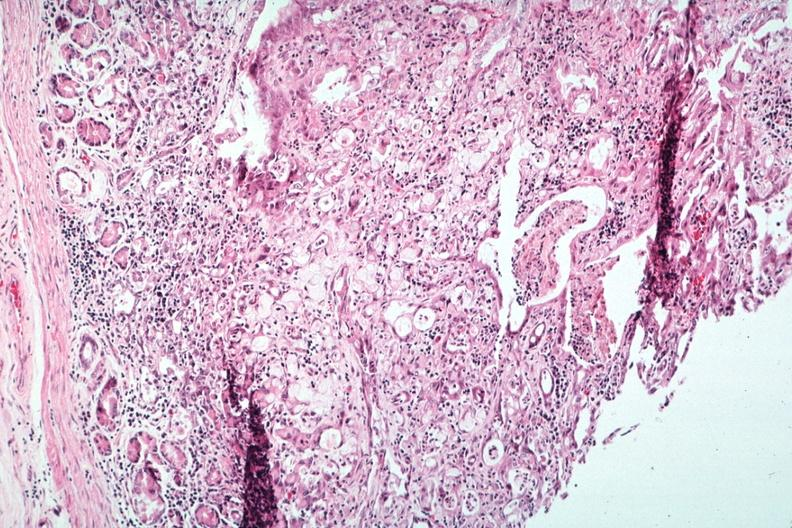s lymph node present?
Answer the question using a single word or phrase. Yes 